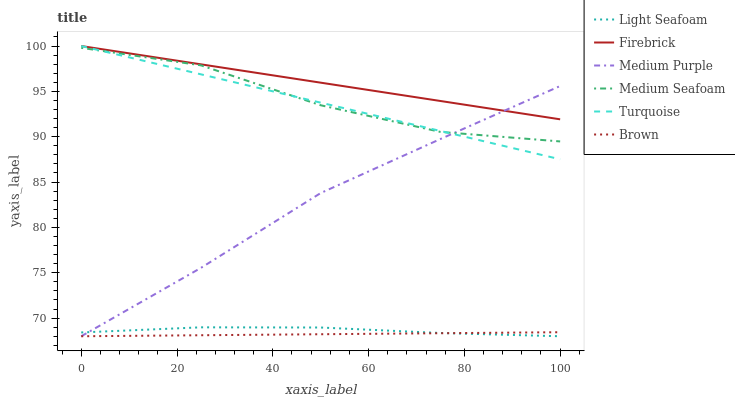Does Brown have the minimum area under the curve?
Answer yes or no. Yes. Does Firebrick have the maximum area under the curve?
Answer yes or no. Yes. Does Turquoise have the minimum area under the curve?
Answer yes or no. No. Does Turquoise have the maximum area under the curve?
Answer yes or no. No. Is Turquoise the smoothest?
Answer yes or no. Yes. Is Medium Seafoam the roughest?
Answer yes or no. Yes. Is Firebrick the smoothest?
Answer yes or no. No. Is Firebrick the roughest?
Answer yes or no. No. Does Brown have the lowest value?
Answer yes or no. Yes. Does Turquoise have the lowest value?
Answer yes or no. No. Does Firebrick have the highest value?
Answer yes or no. Yes. Does Medium Purple have the highest value?
Answer yes or no. No. Is Light Seafoam less than Medium Seafoam?
Answer yes or no. Yes. Is Firebrick greater than Light Seafoam?
Answer yes or no. Yes. Does Medium Seafoam intersect Medium Purple?
Answer yes or no. Yes. Is Medium Seafoam less than Medium Purple?
Answer yes or no. No. Is Medium Seafoam greater than Medium Purple?
Answer yes or no. No. Does Light Seafoam intersect Medium Seafoam?
Answer yes or no. No. 